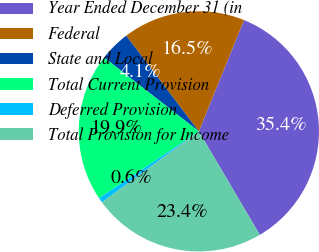Convert chart. <chart><loc_0><loc_0><loc_500><loc_500><pie_chart><fcel>Year Ended December 31 (in<fcel>Federal<fcel>State and Local<fcel>Total Current Provision<fcel>Deferred Provision<fcel>Total Provision for Income<nl><fcel>35.39%<fcel>16.47%<fcel>4.13%<fcel>19.94%<fcel>0.65%<fcel>23.42%<nl></chart> 